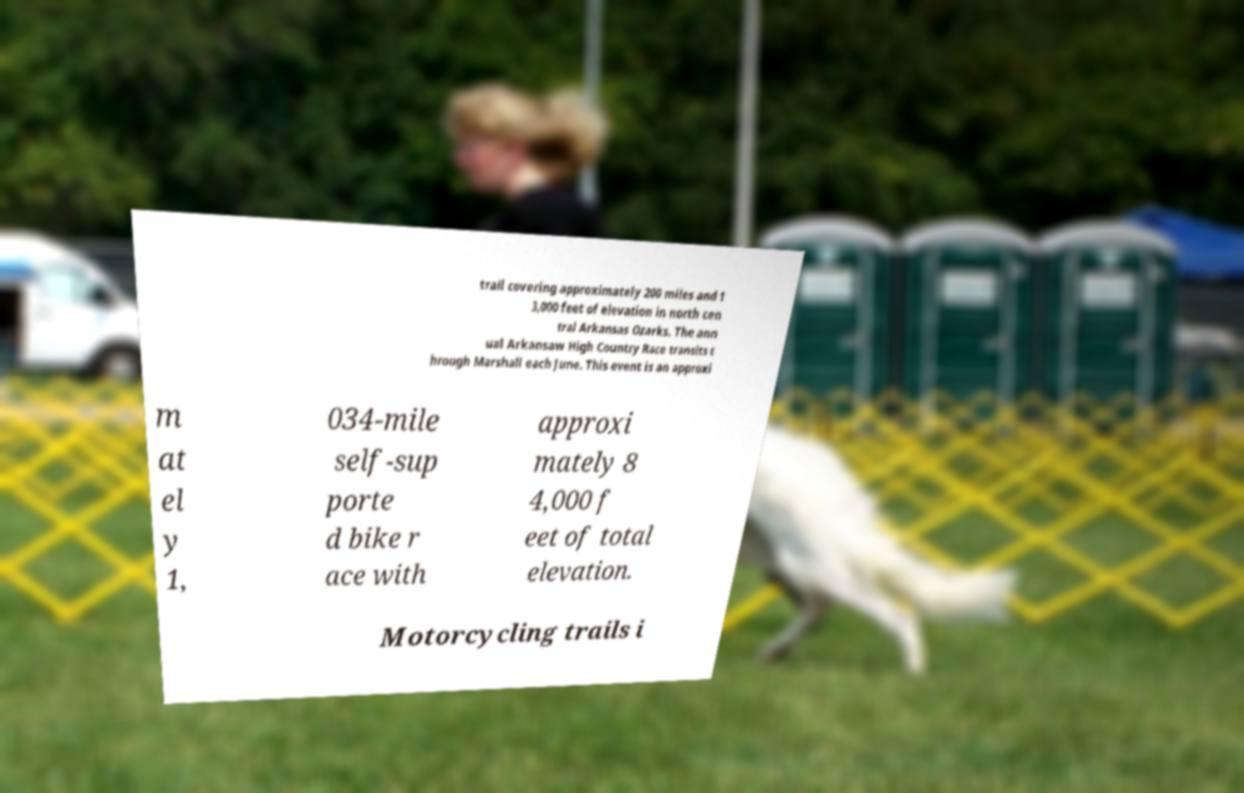Could you extract and type out the text from this image? trail covering approximately 200 miles and 1 3,000 feet of elevation in north cen tral Arkansas Ozarks. The ann ual Arkansaw High Country Race transits t hrough Marshall each June. This event is an approxi m at el y 1, 034-mile self-sup porte d bike r ace with approxi mately 8 4,000 f eet of total elevation. Motorcycling trails i 